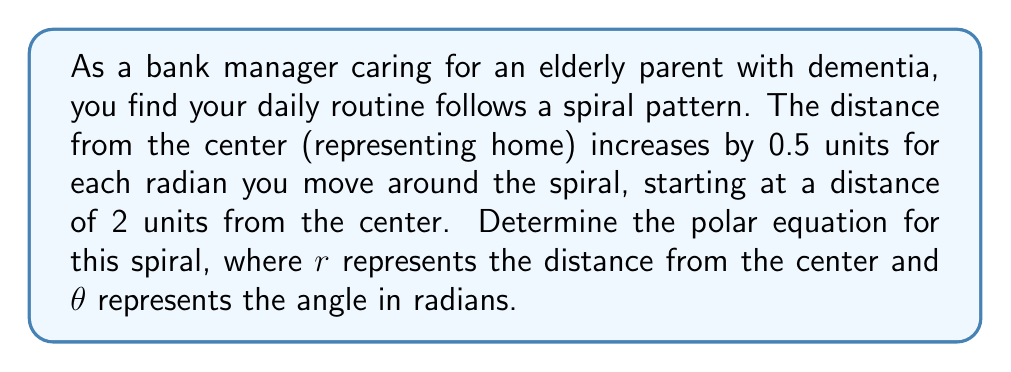Teach me how to tackle this problem. To solve this problem, we need to understand the properties of an Archimedean spiral and how they relate to the given information:

1. In an Archimedean spiral, the distance from the center increases linearly with the angle.

2. The general equation for an Archimedean spiral is:

   $$r = a + b\theta$$

   where $a$ is the starting distance from the center, $b$ is the rate of increase per radian, and $\theta$ is the angle in radians.

3. From the question, we know:
   - The starting distance $a = 2$ units
   - The rate of increase $b = 0.5$ units per radian

4. Substituting these values into the general equation:

   $$r = 2 + 0.5\theta$$

This equation represents the spiral of the caregiver's daily routine, where:
- $r$ is the distance from home (the center)
- $\theta$ is the angle in radians, representing the progression of time and activities throughout the day
- The spiral starts 2 units from the center and grows by 0.5 units for each radian of rotation

[asy]
import graph;
size(200);
real f(real t) {return 2+0.5*t;}
draw(polargraph(f,0,4pi),blue);
draw(circle((0,0),2),dashed);
label("Start",2*dir(0),E);
dot((2,0));
[/asy]
Answer: $$r = 2 + 0.5\theta$$ 